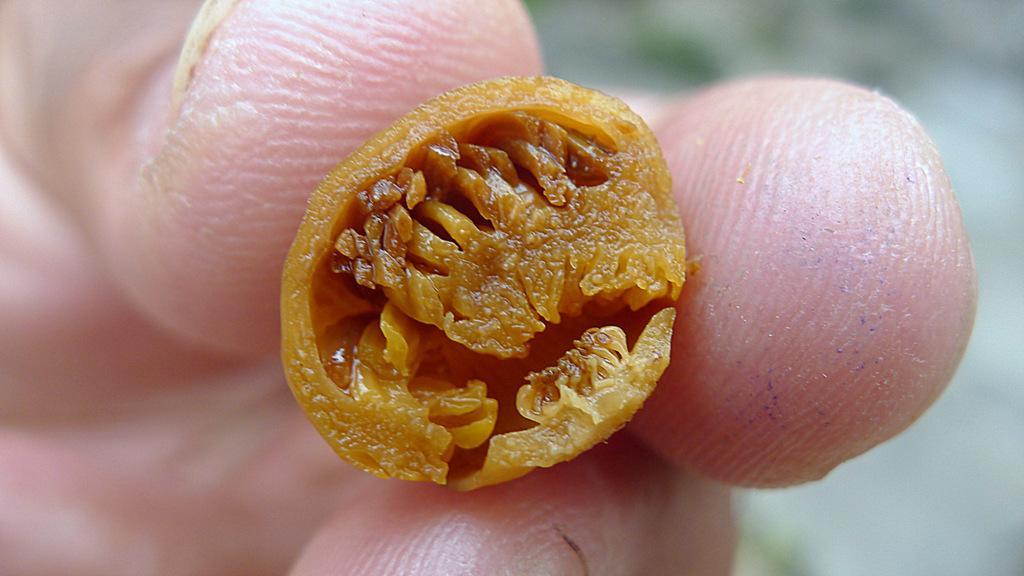Describe this image in one or two sentences. In this image I can see the person holding the brown color object and I can see the blurred background. 